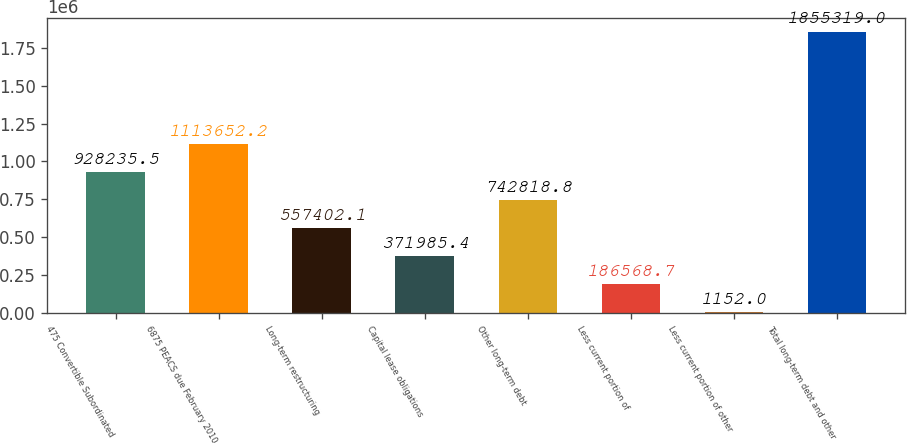Convert chart. <chart><loc_0><loc_0><loc_500><loc_500><bar_chart><fcel>475 Convertible Subordinated<fcel>6875 PEACS due February 2010<fcel>Long-term restructuring<fcel>Capital lease obligations<fcel>Other long-term debt<fcel>Less current portion of<fcel>Less current portion of other<fcel>Total long-term debt and other<nl><fcel>928236<fcel>1.11365e+06<fcel>557402<fcel>371985<fcel>742819<fcel>186569<fcel>1152<fcel>1.85532e+06<nl></chart> 